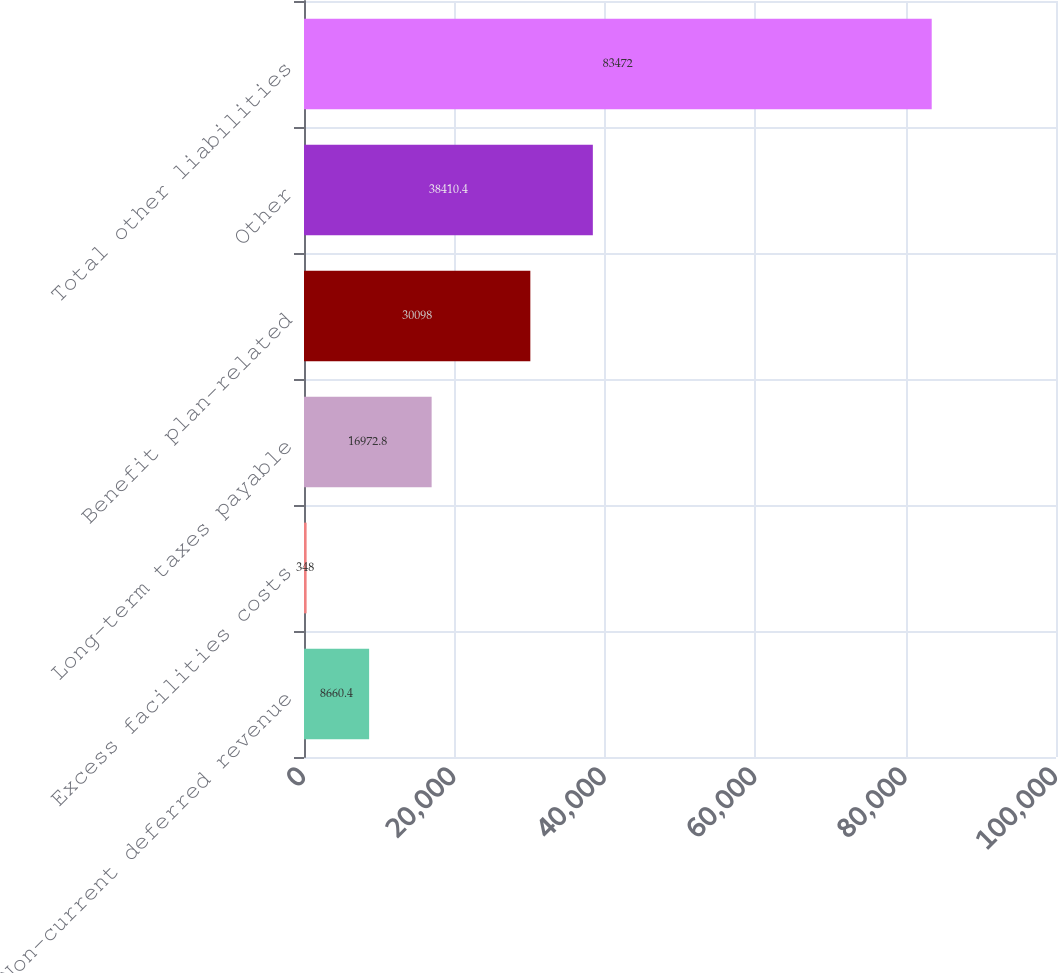Convert chart to OTSL. <chart><loc_0><loc_0><loc_500><loc_500><bar_chart><fcel>Non-current deferred revenue<fcel>Excess facilities costs<fcel>Long-term taxes payable<fcel>Benefit plan-related<fcel>Other<fcel>Total other liabilities<nl><fcel>8660.4<fcel>348<fcel>16972.8<fcel>30098<fcel>38410.4<fcel>83472<nl></chart> 